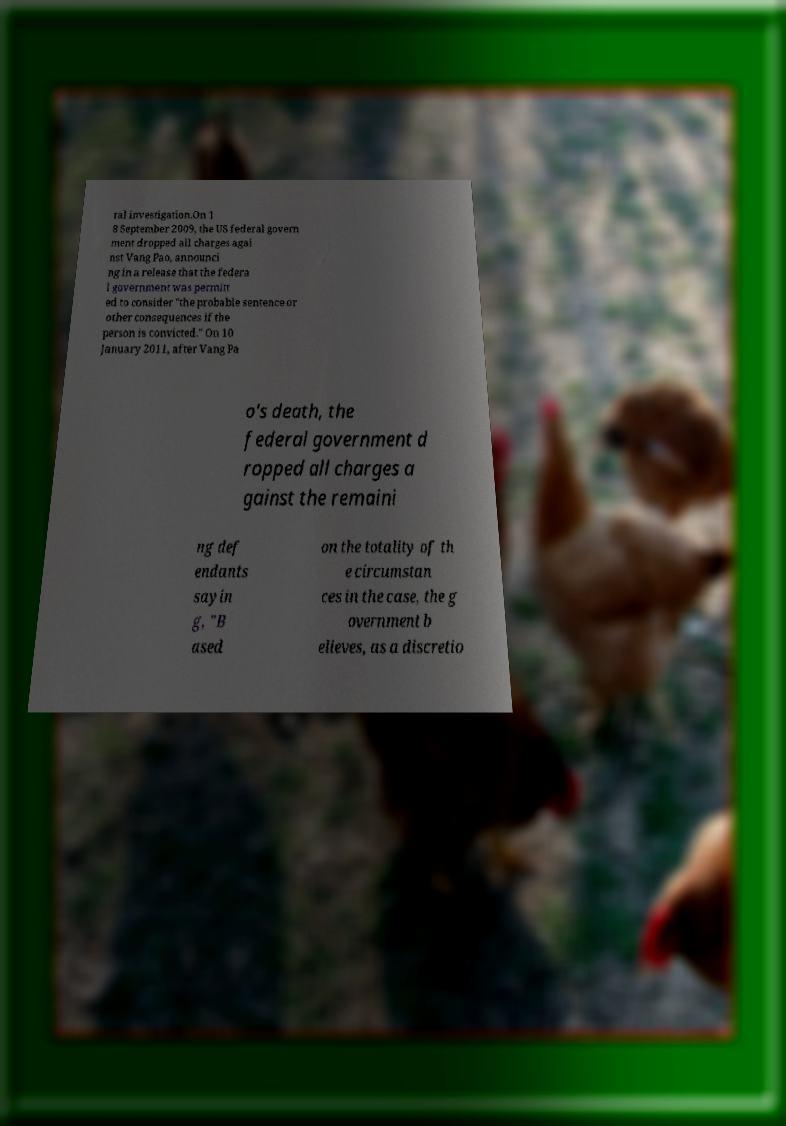For documentation purposes, I need the text within this image transcribed. Could you provide that? ral investigation.On 1 8 September 2009, the US federal govern ment dropped all charges agai nst Vang Pao, announci ng in a release that the federa l government was permitt ed to consider "the probable sentence or other consequences if the person is convicted." On 10 January 2011, after Vang Pa o's death, the federal government d ropped all charges a gainst the remaini ng def endants sayin g, "B ased on the totality of th e circumstan ces in the case, the g overnment b elieves, as a discretio 